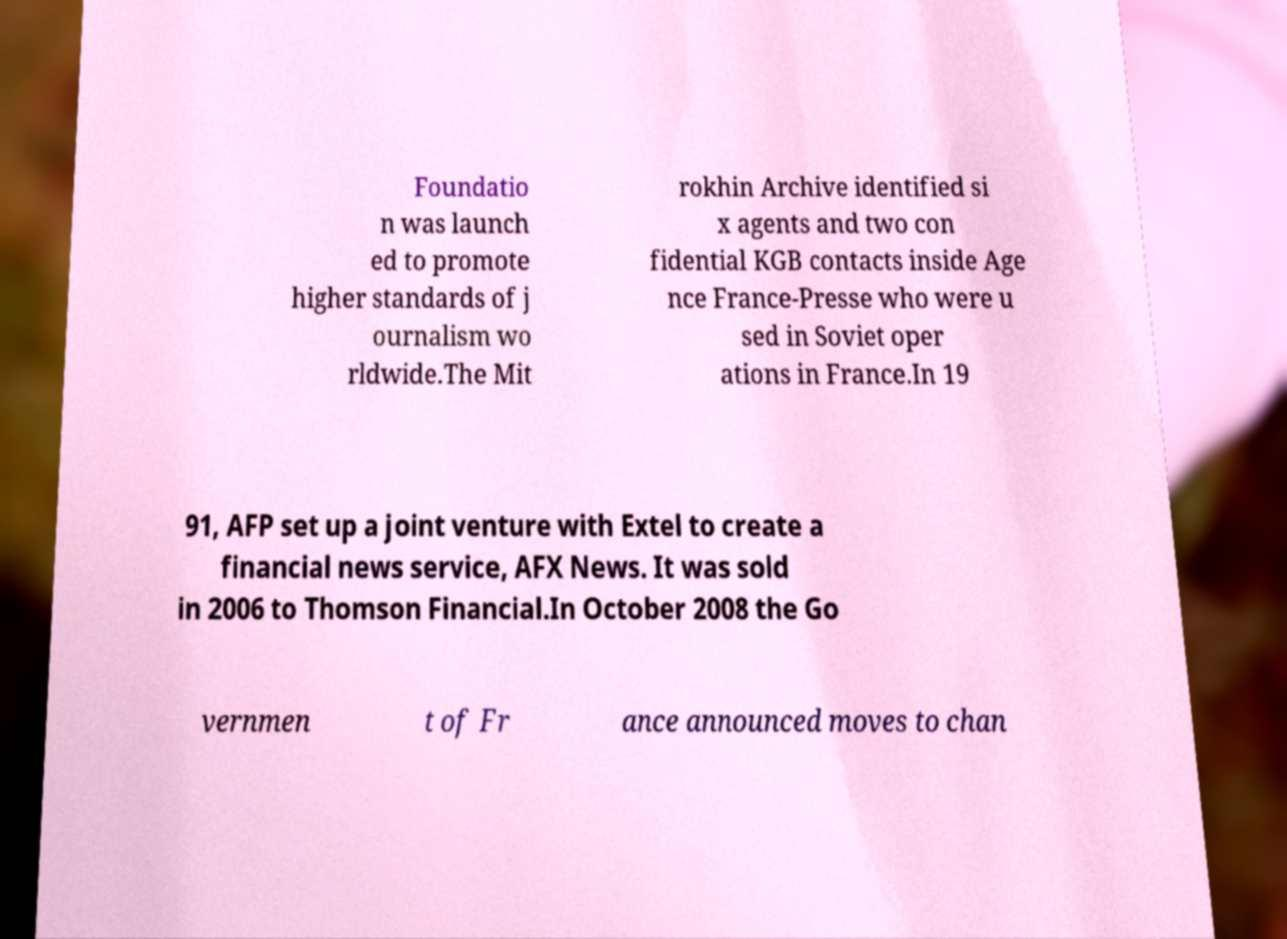What messages or text are displayed in this image? I need them in a readable, typed format. Foundatio n was launch ed to promote higher standards of j ournalism wo rldwide.The Mit rokhin Archive identified si x agents and two con fidential KGB contacts inside Age nce France-Presse who were u sed in Soviet oper ations in France.In 19 91, AFP set up a joint venture with Extel to create a financial news service, AFX News. It was sold in 2006 to Thomson Financial.In October 2008 the Go vernmen t of Fr ance announced moves to chan 